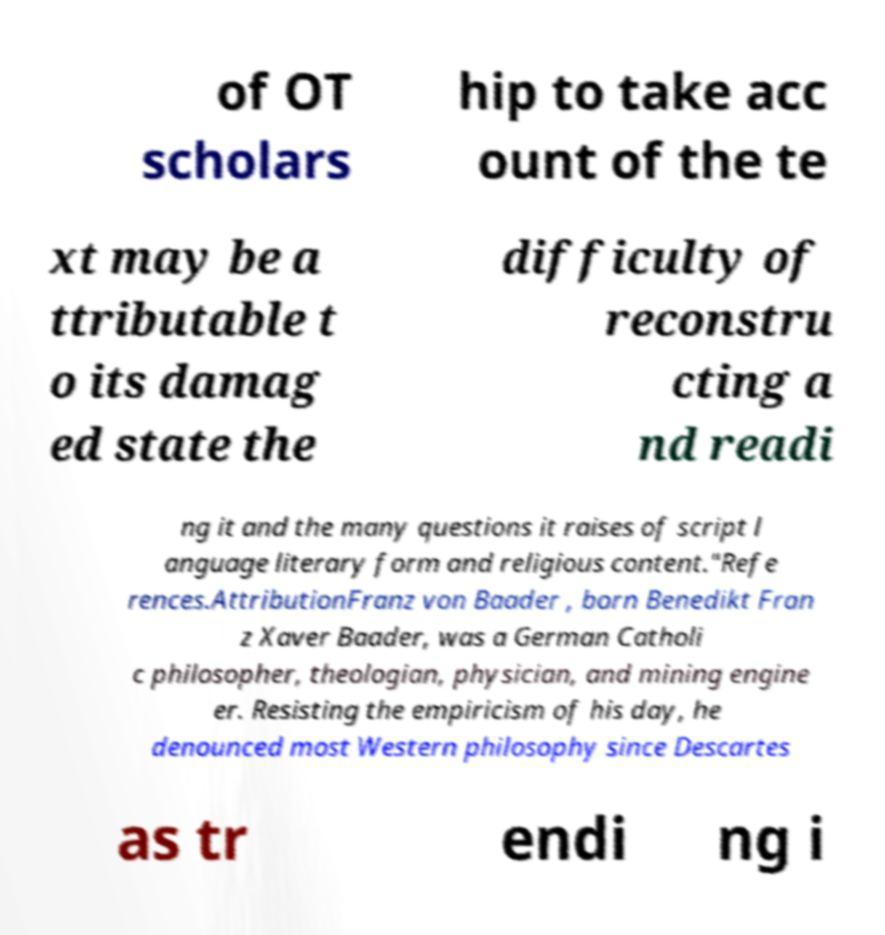Please read and relay the text visible in this image. What does it say? of OT scholars hip to take acc ount of the te xt may be a ttributable t o its damag ed state the difficulty of reconstru cting a nd readi ng it and the many questions it raises of script l anguage literary form and religious content."Refe rences.AttributionFranz von Baader , born Benedikt Fran z Xaver Baader, was a German Catholi c philosopher, theologian, physician, and mining engine er. Resisting the empiricism of his day, he denounced most Western philosophy since Descartes as tr endi ng i 